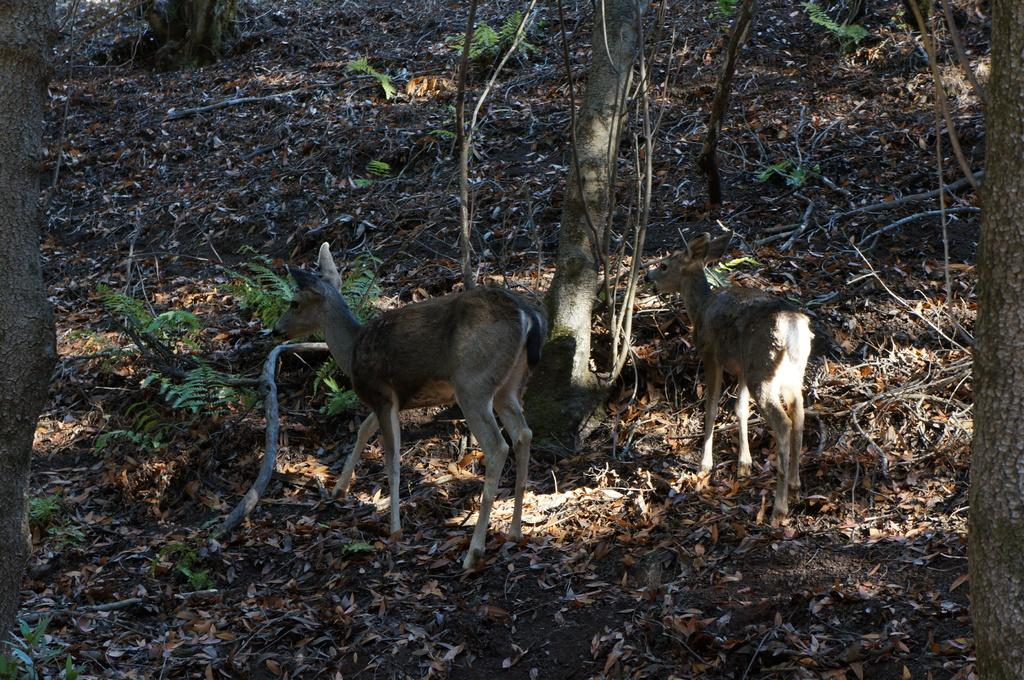What type of natural material can be seen in the image? There are dry leaves in the image. What type of vegetation is present in the image? There are trees and plants in the image. What is the ground made of in the image? Soil is visible in the image. What type of animal can be seen in the image? There is a deer in the image. What type of rhythm can be heard coming from the fan in the image? There is no fan present in the image, so it is not possible to determine any rhythm. 